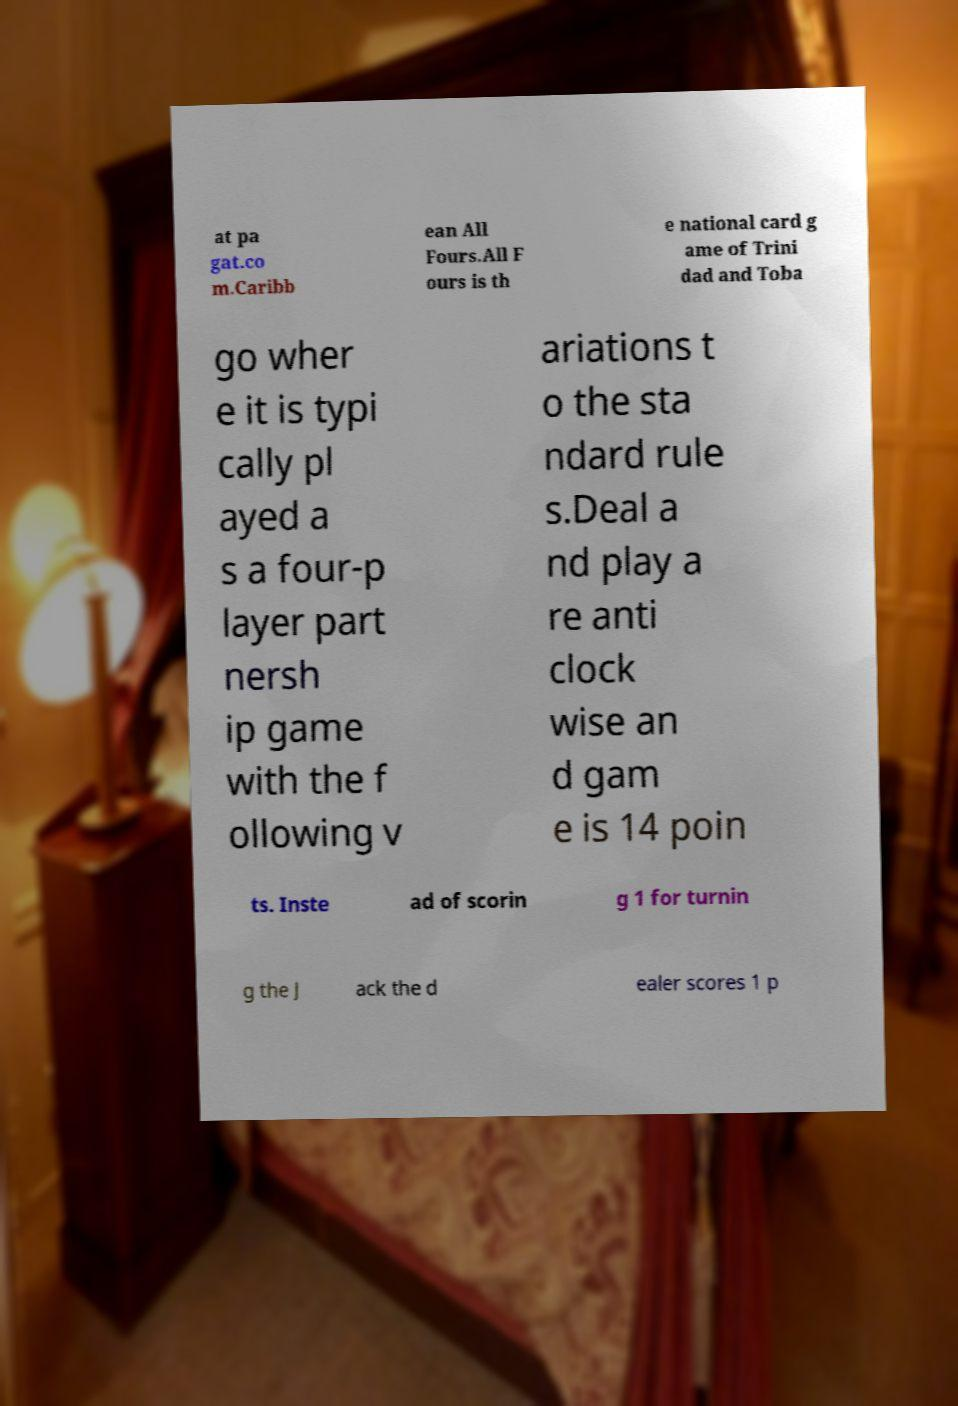Please identify and transcribe the text found in this image. at pa gat.co m.Caribb ean All Fours.All F ours is th e national card g ame of Trini dad and Toba go wher e it is typi cally pl ayed a s a four-p layer part nersh ip game with the f ollowing v ariations t o the sta ndard rule s.Deal a nd play a re anti clock wise an d gam e is 14 poin ts. Inste ad of scorin g 1 for turnin g the J ack the d ealer scores 1 p 